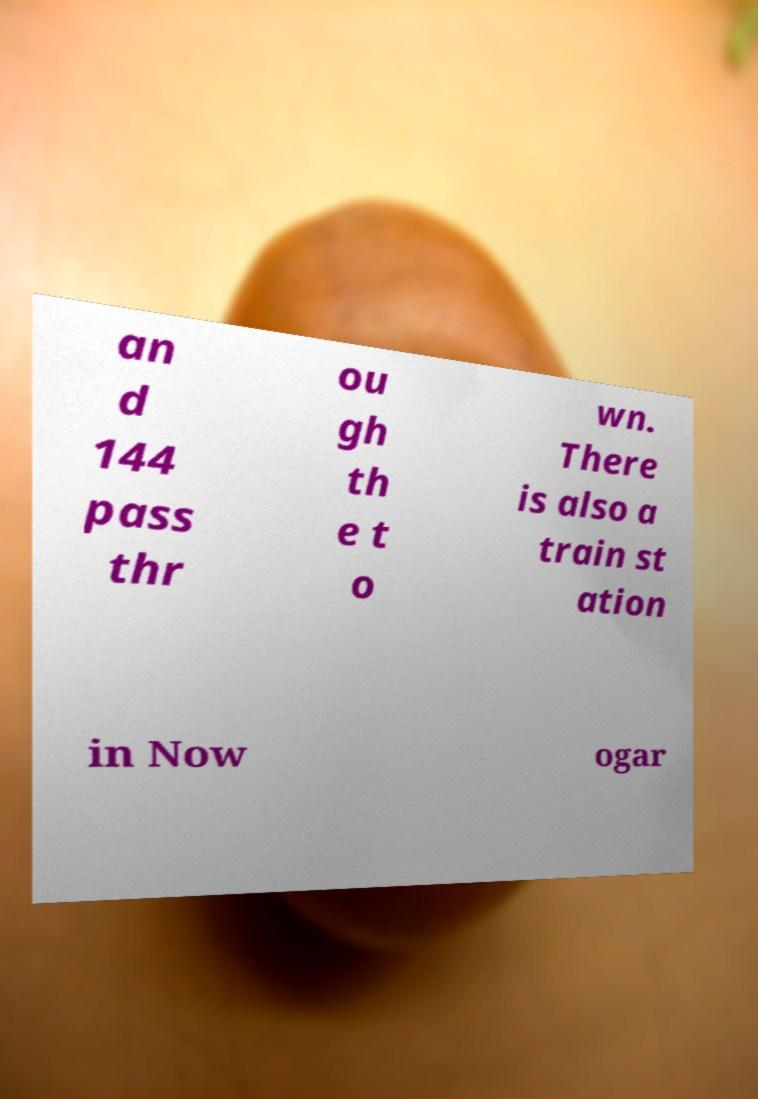Can you read and provide the text displayed in the image?This photo seems to have some interesting text. Can you extract and type it out for me? an d 144 pass thr ou gh th e t o wn. There is also a train st ation in Now ogar 